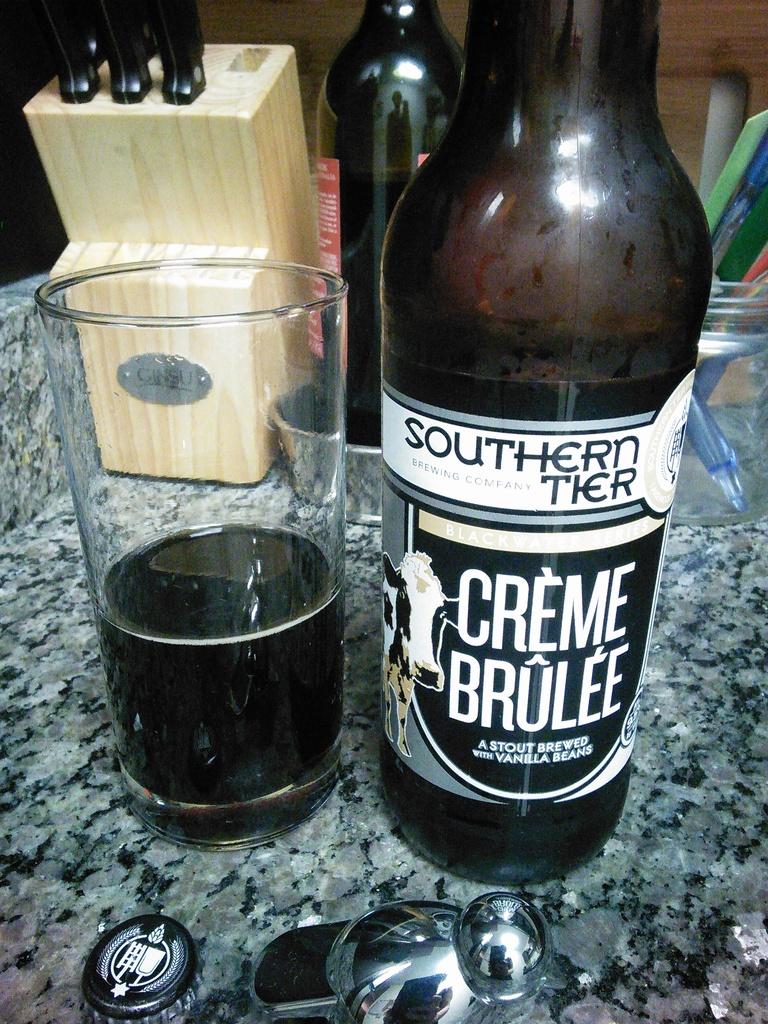What key ingredient was used to brew this beer?
Offer a very short reply. Vanilla beans. What´s the brand on the bottle?
Provide a succinct answer. Southern tier. 